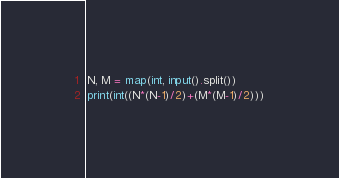<code> <loc_0><loc_0><loc_500><loc_500><_Python_>N, M = map(int, input().split())
print(int((N*(N-1)/2)+(M*(M-1)/2)))</code> 